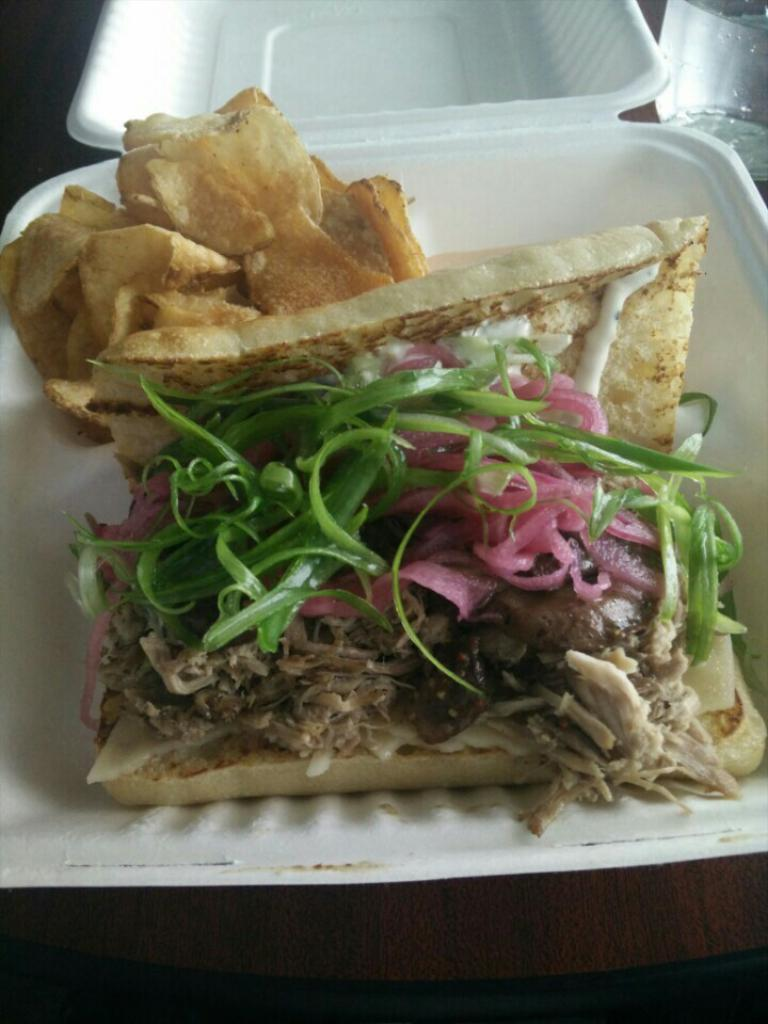What type of container holds the food in the image? There is food in a white bowl in the image. Where is the glass located in the image? The glass is in the top right corner of the image. What material is the surface visible in the image? There is a wooden surface visible in the image. How many chickens are visible in the image? There are no chickens present in the image. What arm is holding the glass in the image? There is no arm visible in the image, as the glass is stationary in the top right corner. 